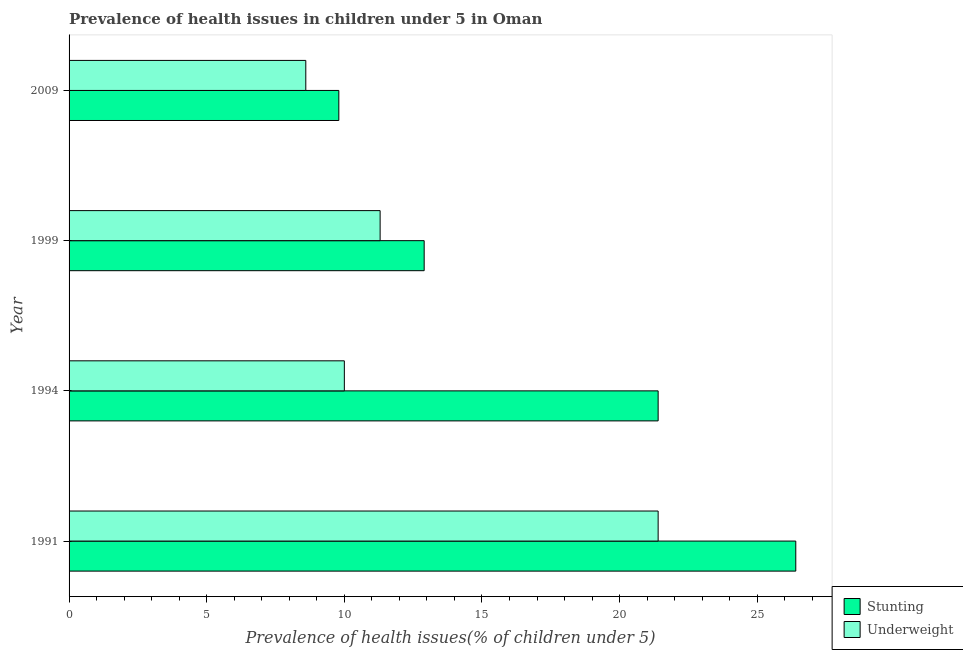Are the number of bars per tick equal to the number of legend labels?
Keep it short and to the point. Yes. How many bars are there on the 3rd tick from the top?
Offer a very short reply. 2. How many bars are there on the 2nd tick from the bottom?
Give a very brief answer. 2. What is the label of the 3rd group of bars from the top?
Your response must be concise. 1994. In how many cases, is the number of bars for a given year not equal to the number of legend labels?
Ensure brevity in your answer.  0. What is the percentage of underweight children in 1999?
Your answer should be compact. 11.3. Across all years, what is the maximum percentage of underweight children?
Give a very brief answer. 21.4. Across all years, what is the minimum percentage of underweight children?
Offer a terse response. 8.6. In which year was the percentage of stunted children maximum?
Offer a very short reply. 1991. What is the total percentage of stunted children in the graph?
Your answer should be very brief. 70.5. What is the difference between the percentage of stunted children in 1991 and that in 1999?
Give a very brief answer. 13.5. What is the difference between the percentage of stunted children in 2009 and the percentage of underweight children in 1991?
Give a very brief answer. -11.6. What is the average percentage of underweight children per year?
Ensure brevity in your answer.  12.82. In the year 1991, what is the difference between the percentage of underweight children and percentage of stunted children?
Your response must be concise. -5. In how many years, is the percentage of stunted children greater than 17 %?
Ensure brevity in your answer.  2. What is the ratio of the percentage of underweight children in 1991 to that in 1999?
Your answer should be very brief. 1.89. Is the difference between the percentage of underweight children in 1991 and 1994 greater than the difference between the percentage of stunted children in 1991 and 1994?
Give a very brief answer. Yes. What is the difference between the highest and the second highest percentage of stunted children?
Make the answer very short. 5. What is the difference between the highest and the lowest percentage of underweight children?
Your response must be concise. 12.8. In how many years, is the percentage of underweight children greater than the average percentage of underweight children taken over all years?
Your answer should be very brief. 1. What does the 1st bar from the top in 1994 represents?
Your answer should be compact. Underweight. What does the 1st bar from the bottom in 2009 represents?
Your answer should be compact. Stunting. Are all the bars in the graph horizontal?
Provide a succinct answer. Yes. What is the difference between two consecutive major ticks on the X-axis?
Offer a terse response. 5. Does the graph contain grids?
Provide a short and direct response. No. What is the title of the graph?
Give a very brief answer. Prevalence of health issues in children under 5 in Oman. What is the label or title of the X-axis?
Keep it short and to the point. Prevalence of health issues(% of children under 5). What is the label or title of the Y-axis?
Your answer should be very brief. Year. What is the Prevalence of health issues(% of children under 5) of Stunting in 1991?
Give a very brief answer. 26.4. What is the Prevalence of health issues(% of children under 5) of Underweight in 1991?
Your answer should be compact. 21.4. What is the Prevalence of health issues(% of children under 5) in Stunting in 1994?
Keep it short and to the point. 21.4. What is the Prevalence of health issues(% of children under 5) of Underweight in 1994?
Make the answer very short. 10. What is the Prevalence of health issues(% of children under 5) of Stunting in 1999?
Make the answer very short. 12.9. What is the Prevalence of health issues(% of children under 5) of Underweight in 1999?
Make the answer very short. 11.3. What is the Prevalence of health issues(% of children under 5) of Stunting in 2009?
Provide a short and direct response. 9.8. What is the Prevalence of health issues(% of children under 5) in Underweight in 2009?
Give a very brief answer. 8.6. Across all years, what is the maximum Prevalence of health issues(% of children under 5) in Stunting?
Your answer should be compact. 26.4. Across all years, what is the maximum Prevalence of health issues(% of children under 5) of Underweight?
Ensure brevity in your answer.  21.4. Across all years, what is the minimum Prevalence of health issues(% of children under 5) in Stunting?
Ensure brevity in your answer.  9.8. Across all years, what is the minimum Prevalence of health issues(% of children under 5) in Underweight?
Offer a terse response. 8.6. What is the total Prevalence of health issues(% of children under 5) in Stunting in the graph?
Offer a very short reply. 70.5. What is the total Prevalence of health issues(% of children under 5) in Underweight in the graph?
Keep it short and to the point. 51.3. What is the difference between the Prevalence of health issues(% of children under 5) of Stunting in 1991 and that in 1994?
Offer a very short reply. 5. What is the difference between the Prevalence of health issues(% of children under 5) of Underweight in 1991 and that in 2009?
Offer a terse response. 12.8. What is the difference between the Prevalence of health issues(% of children under 5) of Stunting in 1994 and that in 2009?
Provide a succinct answer. 11.6. What is the difference between the Prevalence of health issues(% of children under 5) in Underweight in 1994 and that in 2009?
Your response must be concise. 1.4. What is the difference between the Prevalence of health issues(% of children under 5) of Underweight in 1999 and that in 2009?
Ensure brevity in your answer.  2.7. What is the difference between the Prevalence of health issues(% of children under 5) of Stunting in 1991 and the Prevalence of health issues(% of children under 5) of Underweight in 1999?
Provide a short and direct response. 15.1. What is the difference between the Prevalence of health issues(% of children under 5) in Stunting in 1994 and the Prevalence of health issues(% of children under 5) in Underweight in 1999?
Ensure brevity in your answer.  10.1. What is the difference between the Prevalence of health issues(% of children under 5) in Stunting in 1994 and the Prevalence of health issues(% of children under 5) in Underweight in 2009?
Give a very brief answer. 12.8. What is the difference between the Prevalence of health issues(% of children under 5) in Stunting in 1999 and the Prevalence of health issues(% of children under 5) in Underweight in 2009?
Keep it short and to the point. 4.3. What is the average Prevalence of health issues(% of children under 5) in Stunting per year?
Make the answer very short. 17.62. What is the average Prevalence of health issues(% of children under 5) of Underweight per year?
Ensure brevity in your answer.  12.82. In the year 1991, what is the difference between the Prevalence of health issues(% of children under 5) of Stunting and Prevalence of health issues(% of children under 5) of Underweight?
Your answer should be very brief. 5. In the year 1994, what is the difference between the Prevalence of health issues(% of children under 5) in Stunting and Prevalence of health issues(% of children under 5) in Underweight?
Your answer should be very brief. 11.4. What is the ratio of the Prevalence of health issues(% of children under 5) of Stunting in 1991 to that in 1994?
Your response must be concise. 1.23. What is the ratio of the Prevalence of health issues(% of children under 5) of Underweight in 1991 to that in 1994?
Make the answer very short. 2.14. What is the ratio of the Prevalence of health issues(% of children under 5) of Stunting in 1991 to that in 1999?
Ensure brevity in your answer.  2.05. What is the ratio of the Prevalence of health issues(% of children under 5) of Underweight in 1991 to that in 1999?
Provide a succinct answer. 1.89. What is the ratio of the Prevalence of health issues(% of children under 5) in Stunting in 1991 to that in 2009?
Offer a very short reply. 2.69. What is the ratio of the Prevalence of health issues(% of children under 5) of Underweight in 1991 to that in 2009?
Provide a short and direct response. 2.49. What is the ratio of the Prevalence of health issues(% of children under 5) of Stunting in 1994 to that in 1999?
Give a very brief answer. 1.66. What is the ratio of the Prevalence of health issues(% of children under 5) in Underweight in 1994 to that in 1999?
Provide a short and direct response. 0.89. What is the ratio of the Prevalence of health issues(% of children under 5) in Stunting in 1994 to that in 2009?
Your response must be concise. 2.18. What is the ratio of the Prevalence of health issues(% of children under 5) in Underweight in 1994 to that in 2009?
Offer a very short reply. 1.16. What is the ratio of the Prevalence of health issues(% of children under 5) in Stunting in 1999 to that in 2009?
Offer a terse response. 1.32. What is the ratio of the Prevalence of health issues(% of children under 5) in Underweight in 1999 to that in 2009?
Offer a very short reply. 1.31. What is the difference between the highest and the second highest Prevalence of health issues(% of children under 5) in Stunting?
Your response must be concise. 5. What is the difference between the highest and the second highest Prevalence of health issues(% of children under 5) of Underweight?
Your response must be concise. 10.1. 